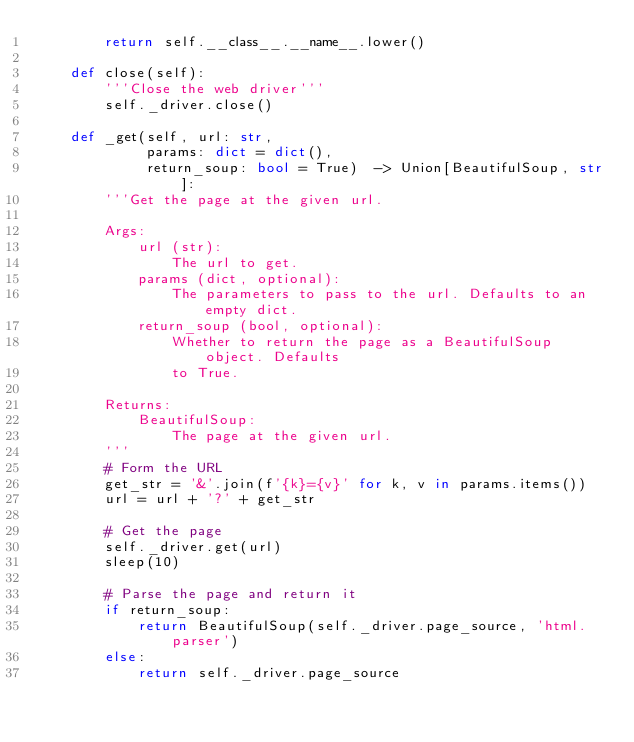<code> <loc_0><loc_0><loc_500><loc_500><_Python_>        return self.__class__.__name__.lower()

    def close(self):
        '''Close the web driver'''
        self._driver.close()

    def _get(self, url: str,
             params: dict = dict(),
             return_soup: bool = True)  -> Union[BeautifulSoup, str]:
        '''Get the page at the given url.

        Args:
            url (str):
                The url to get.
            params (dict, optional):
                The parameters to pass to the url. Defaults to an empty dict.
            return_soup (bool, optional):
                Whether to return the page as a BeautifulSoup object. Defaults
                to True.

        Returns:
            BeautifulSoup:
                The page at the given url.
        '''
        # Form the URL
        get_str = '&'.join(f'{k}={v}' for k, v in params.items())
        url = url + '?' + get_str

        # Get the page
        self._driver.get(url)
        sleep(10)

        # Parse the page and return it
        if return_soup:
            return BeautifulSoup(self._driver.page_source, 'html.parser')
        else:
            return self._driver.page_source
</code> 